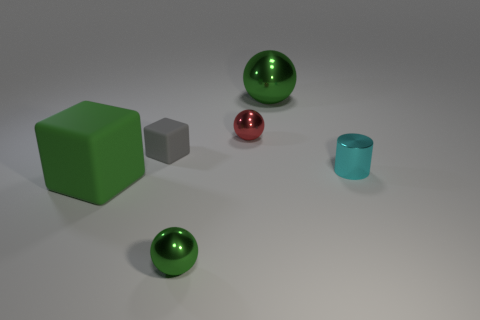Add 4 small purple matte cylinders. How many objects exist? 10 Subtract all cubes. How many objects are left? 4 Subtract all small brown cylinders. Subtract all big green matte things. How many objects are left? 5 Add 1 small spheres. How many small spheres are left? 3 Add 2 green matte things. How many green matte things exist? 3 Subtract 0 gray cylinders. How many objects are left? 6 